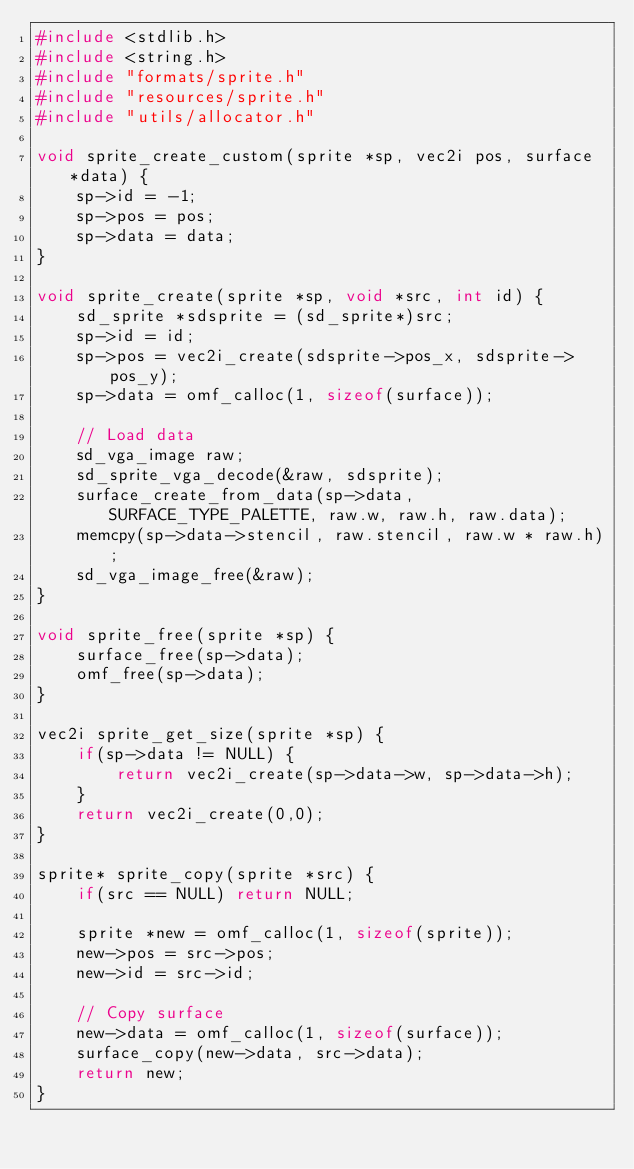<code> <loc_0><loc_0><loc_500><loc_500><_C_>#include <stdlib.h>
#include <string.h>
#include "formats/sprite.h"
#include "resources/sprite.h"
#include "utils/allocator.h"

void sprite_create_custom(sprite *sp, vec2i pos, surface *data) {
    sp->id = -1;
    sp->pos = pos;
    sp->data = data;
}

void sprite_create(sprite *sp, void *src, int id) {
    sd_sprite *sdsprite = (sd_sprite*)src;
    sp->id = id;
    sp->pos = vec2i_create(sdsprite->pos_x, sdsprite->pos_y);
    sp->data = omf_calloc(1, sizeof(surface));

    // Load data
    sd_vga_image raw;
    sd_sprite_vga_decode(&raw, sdsprite);
    surface_create_from_data(sp->data, SURFACE_TYPE_PALETTE, raw.w, raw.h, raw.data);
    memcpy(sp->data->stencil, raw.stencil, raw.w * raw.h);
    sd_vga_image_free(&raw);
}

void sprite_free(sprite *sp) {
    surface_free(sp->data);
    omf_free(sp->data);
}

vec2i sprite_get_size(sprite *sp) {
    if(sp->data != NULL) {
        return vec2i_create(sp->data->w, sp->data->h);
    }
    return vec2i_create(0,0);
}

sprite* sprite_copy(sprite *src) {
    if(src == NULL) return NULL;

    sprite *new = omf_calloc(1, sizeof(sprite));
    new->pos = src->pos;
    new->id = src->id;

    // Copy surface
    new->data = omf_calloc(1, sizeof(surface));
    surface_copy(new->data, src->data);
    return new;
}
</code> 